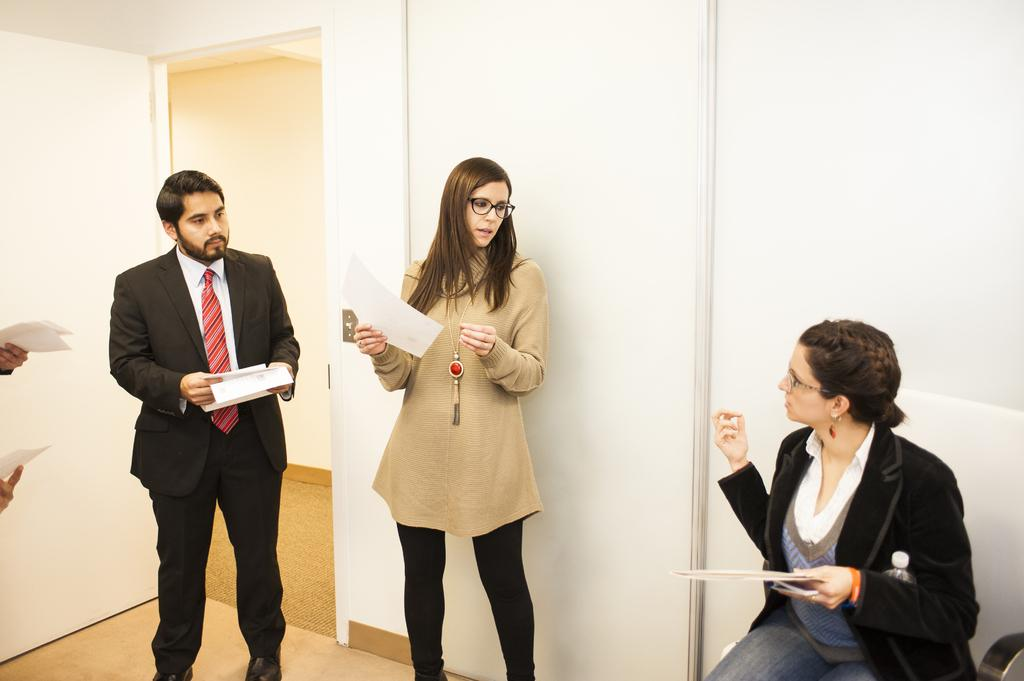What are the people in the image holding? The people in the image are holding papers. Can you describe the position of one of the people in the image? There is a person sitting on a chair in the image. What can be seen in the background of the image? There is a door and a wall in the background of the image. What type of peace can be seen in the image? There is no reference to peace in the image; it features people holding papers and a person sitting on a chair with a door and a wall in the background. 